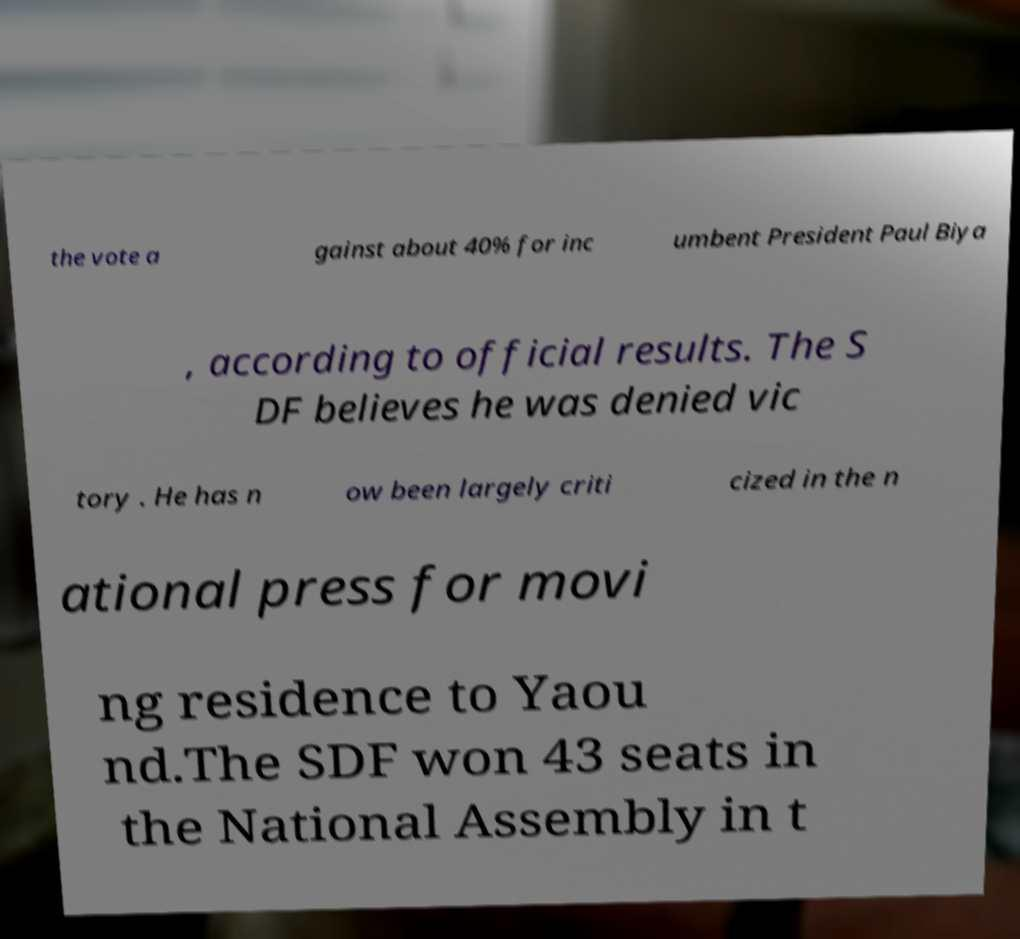There's text embedded in this image that I need extracted. Can you transcribe it verbatim? the vote a gainst about 40% for inc umbent President Paul Biya , according to official results. The S DF believes he was denied vic tory . He has n ow been largely criti cized in the n ational press for movi ng residence to Yaou nd.The SDF won 43 seats in the National Assembly in t 